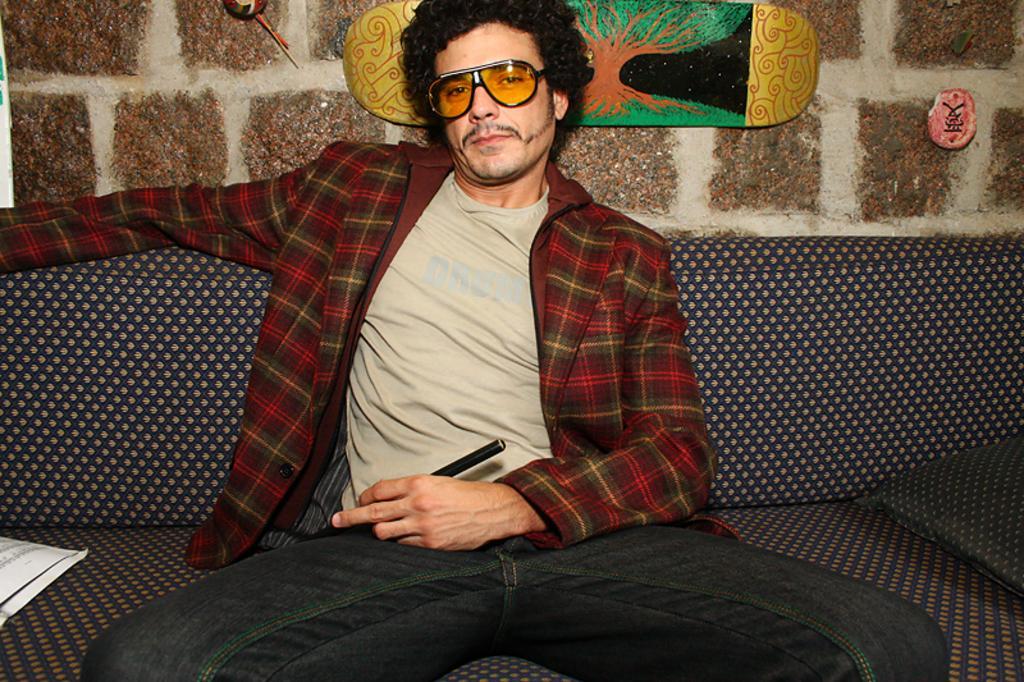Could you give a brief overview of what you see in this image? In the image we can see a man wearing clothes, goggles and he is sitting. He is holding the stick in his hand. Here we can see couch, stone wall and skateboard stick to the wall. On the couch we can see pillow and paper. 